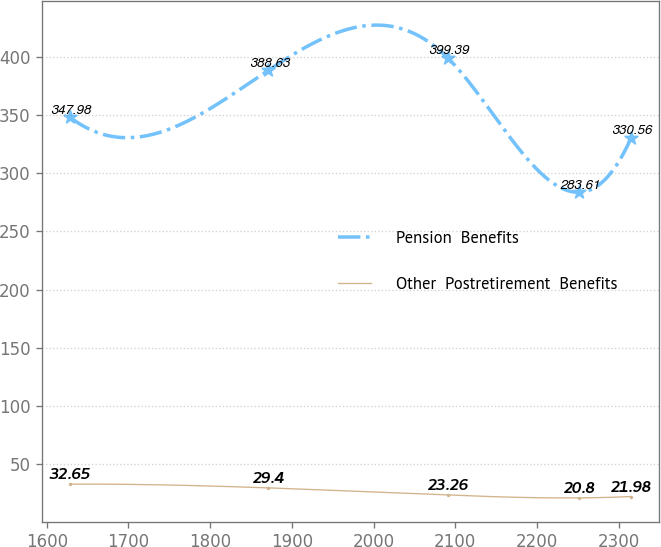Convert chart. <chart><loc_0><loc_0><loc_500><loc_500><line_chart><ecel><fcel>Pension  Benefits<fcel>Other  Postretirement  Benefits<nl><fcel>1628.82<fcel>347.98<fcel>32.65<nl><fcel>1871.41<fcel>388.63<fcel>29.4<nl><fcel>2090.65<fcel>399.39<fcel>23.26<nl><fcel>2251.83<fcel>283.61<fcel>20.8<nl><fcel>2315.31<fcel>330.56<fcel>21.98<nl></chart> 